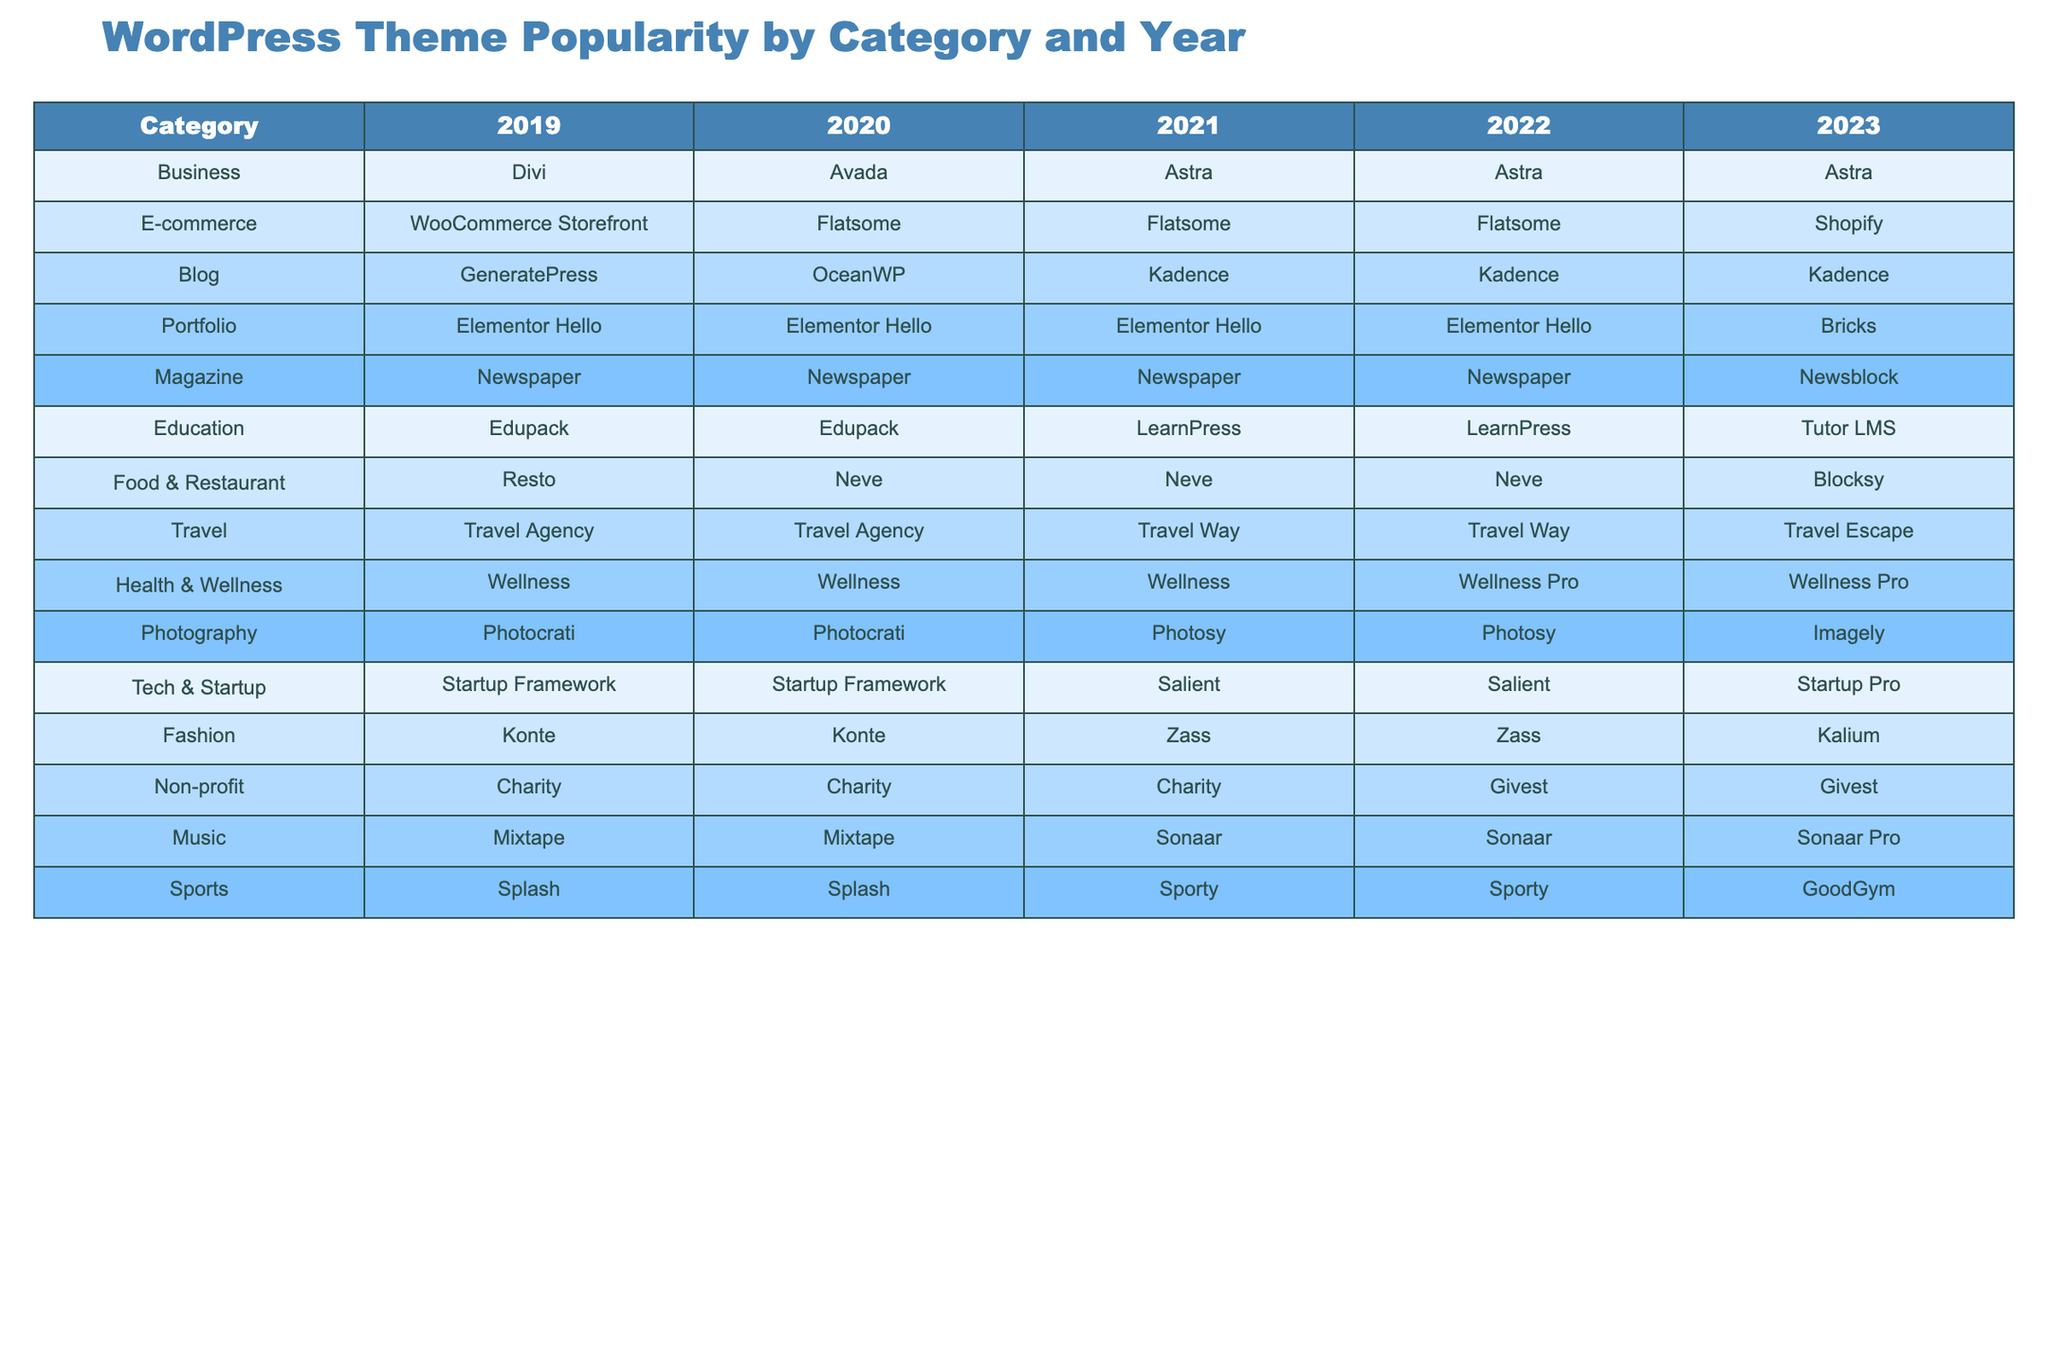What was the most popular theme for the Business category in 2022? In 2022, the Business category shows "Astra" as the most popular theme used.
Answer: Astra Which theme was consistently popular in the Portfolio category from 2019 to 2023? The Portfolio category lists "Elementor Hello" for the years 2019, 2020, 2021, and 2022, indicating it was consistently popular until 2023 when "Bricks" took over.
Answer: Elementor Hello What theme did the Food & Restaurant category shift to in 2023? In 2023, the Food & Restaurant category shows a shift from "Neve" to "Blocksy."
Answer: Blocksy Was "Astra" the top theme in the Business category for all the years listed? "Astra" was only the top theme in the Business category for the years 2022 and 2023, while "Divi" and "Avada" were the top in earlier years.
Answer: No How many different themes were popular in the Travel category between 2019 and 2023? Analyzing the Travel category shows "Travel Agency" in 2019 and 2020, "Travel Way" in 2021 and 2022, and "Travel Escape" in 2023, totaling 4 different themes.
Answer: Four Which category had the same theme in the years 2019, 2020, and 2021? The Education category had the same theme "Edupack" in the years 2019 and 2020, while "LearnPress" was used in 2021, so this category did not have the same theme for all three years.
Answer: No categories had the same theme for all three years What trend can be observed in the Blog category themes from 2019 to 2023? The Blog category shows a progressive increase in the popularity of "Kadence," which replaced "GeneratePress" in 2021 and remained the top theme through 2023.
Answer: Increasing popularity of Kadence What was the most frequently mentioned theme overall from 2019 to 2023? Observing each year, "Astra" is repeated three times, making it the most frequently mentioned theme overall.
Answer: Astra Which category had a consistent theme presence with little change over the years? The Health & Wellness category consistently used "Wellness" in 2019, 2020, and 2021, transitioning only in 2022 and 2023 to "Wellness Pro."
Answer: Health & Wellness What percentage of categories saw a theme change in 2023? There are 10 categories, and 7 of them changed their top themes in 2023, resulting in a change for 70% of categories.
Answer: 70% 